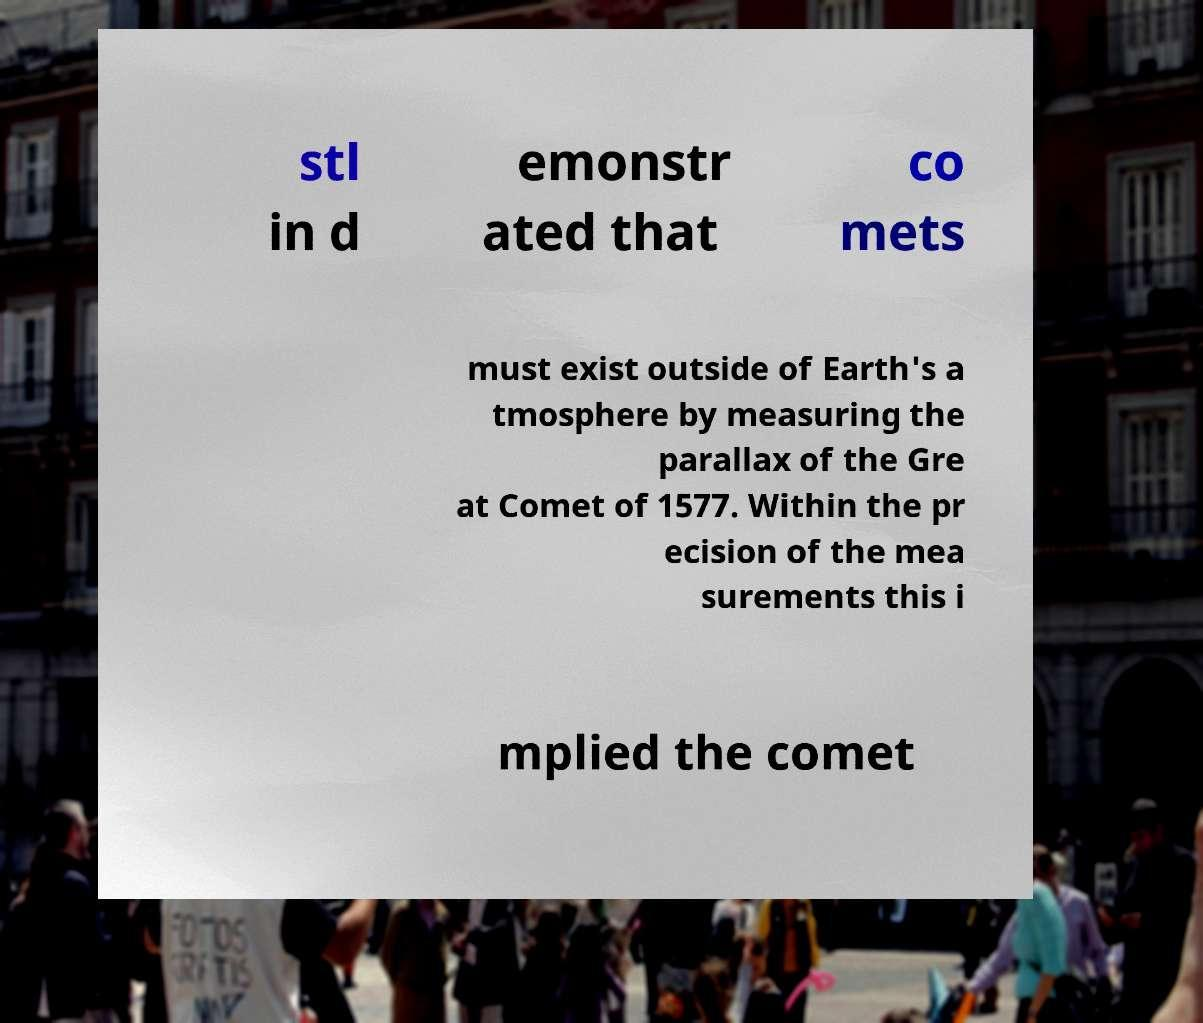Could you extract and type out the text from this image? stl in d emonstr ated that co mets must exist outside of Earth's a tmosphere by measuring the parallax of the Gre at Comet of 1577. Within the pr ecision of the mea surements this i mplied the comet 